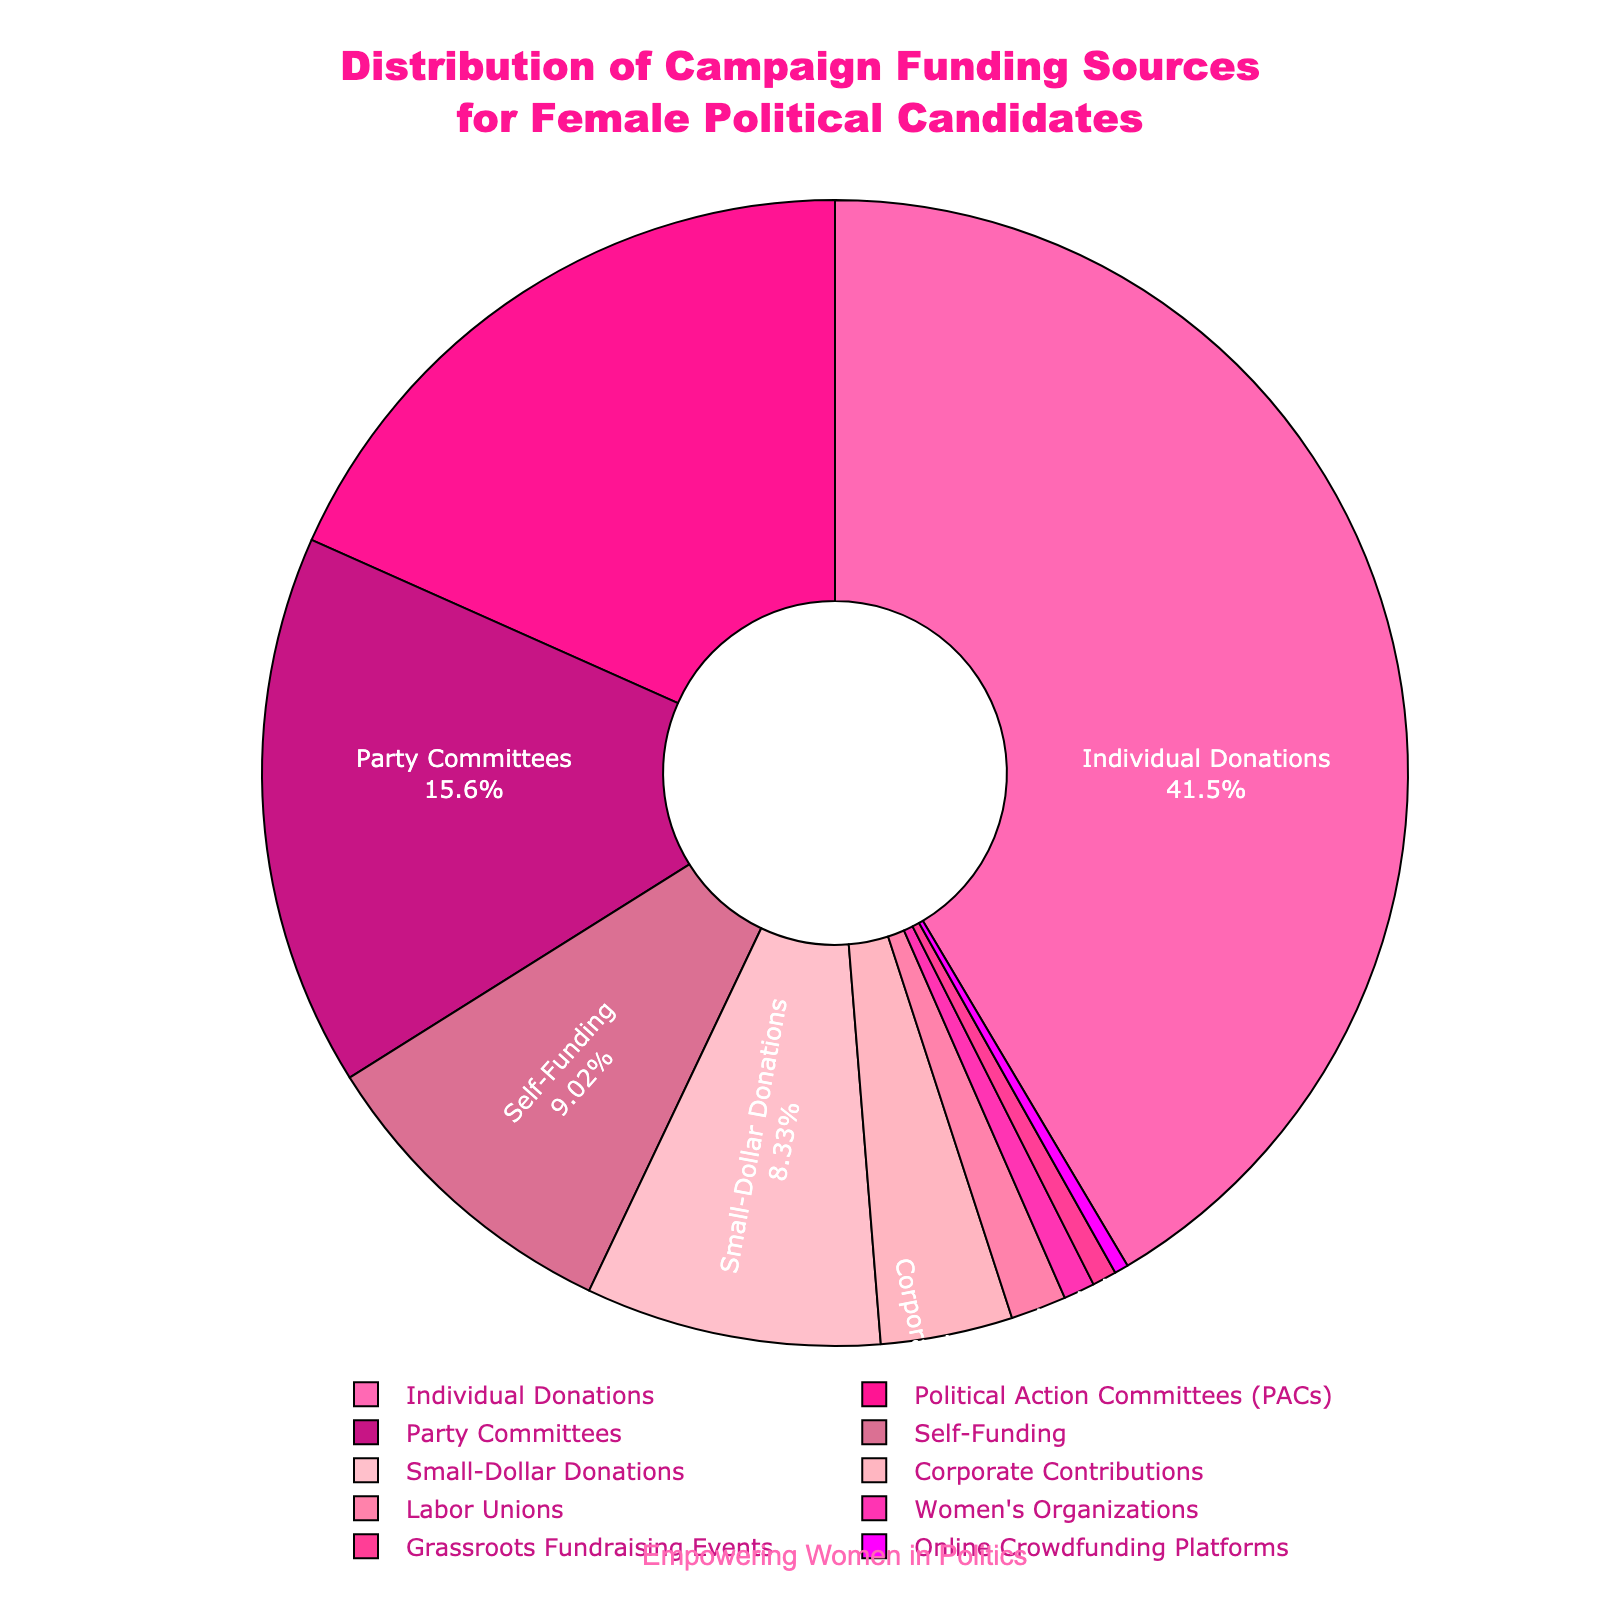What's the largest source of campaign funding for female political candidates? The largest slice of the pie chart represents the source with the highest percentage. In this case, the 42.3% segment for Individual Donations is the largest.
Answer: Individual Donations Which sources contribute less than 5% to female political candidates' campaign funding? By examining the pie slices with percentages less than 5%, the sources are Corporate Contributions (3.8%), Labor Unions (1.6%), Women's Organizations (0.9%), Grassroots Fundraising Events (0.7%), and Online Crowdfunding Platforms (0.4%).
Answer: Corporate Contributions, Labor Unions, Women's Organizations, Grassroots Fundraising Events, Online Crowdfunding Platforms What is the combined percentage of Political Action Committees (PACs) and Party Committees? Sum the percentages of Political Action Committees (18.7%) and Party Committees (15.9%). Their combined percentage is 18.7 + 15.9.
Answer: 34.6% How many sources contribute more to campaign funding than Self-Funding? Compare Self-Funding (9.2%) to other sources. The sources with higher percentages are Individual Donations (42.3%), Political Action Committees (18.7%), and Party Committees (15.9%), totaling 3 sources.
Answer: 3 Which is more significant in campaign funding: Labor Unions or Women's Organizations? Compare the slices for Labor Unions (1.6%) and Women's Organizations (0.9%). Labor Unions have a higher percentage.
Answer: Labor Unions What is the total percentage of funding that comes from non-individual sources? Subtract the percentage of Individual Donations (42.3%) from 100%. The total of non-individual sources is 100 - 42.3.
Answer: 57.7% Which source with a pink-shaded slice contributes the least to campaign funding? Identify the smallest pink-shaded slice in the pie chart. The smallest slice corresponds to the 0.4% from Online Crowdfunding Platforms.
Answer: Online Crowdfunding Platforms Is the percentage contributed by Political Action Committees (PACs) greater than the combined percentage of Small-Dollar Donations and Women's Organizations? Compare PACs (18.7%) to the combined percentage of Small-Dollar Donations (8.5%) and Women's Organizations (0.9%), which is 8.5 + 0.9 = 9.4%. Since 18.7% > 9.4%, PACs contribute more.
Answer: Yes 